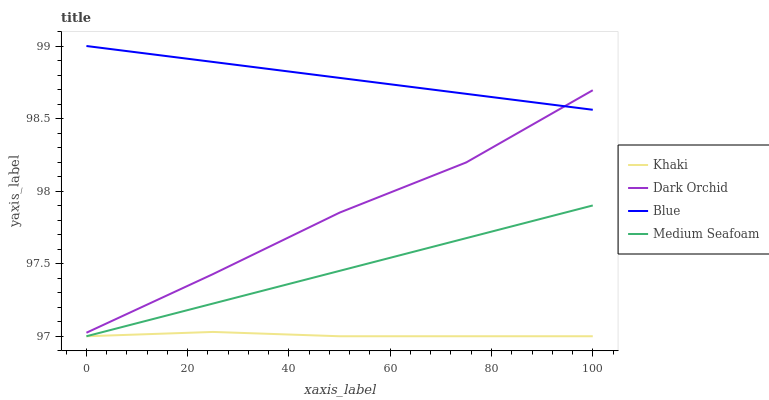Does Medium Seafoam have the minimum area under the curve?
Answer yes or no. No. Does Medium Seafoam have the maximum area under the curve?
Answer yes or no. No. Is Khaki the smoothest?
Answer yes or no. No. Is Khaki the roughest?
Answer yes or no. No. Does Dark Orchid have the lowest value?
Answer yes or no. No. Does Medium Seafoam have the highest value?
Answer yes or no. No. Is Khaki less than Blue?
Answer yes or no. Yes. Is Blue greater than Medium Seafoam?
Answer yes or no. Yes. Does Khaki intersect Blue?
Answer yes or no. No. 